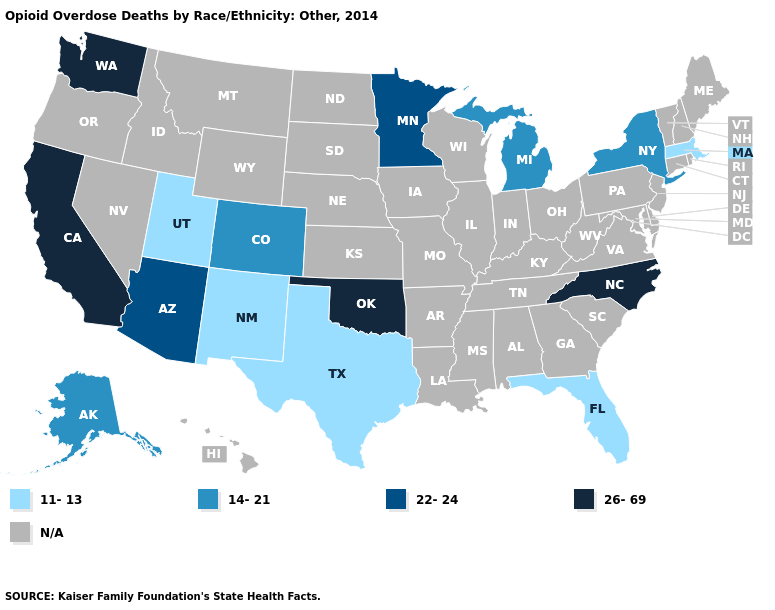Among the states that border Virginia , which have the lowest value?
Keep it brief. North Carolina. Name the states that have a value in the range N/A?
Be succinct. Alabama, Arkansas, Connecticut, Delaware, Georgia, Hawaii, Idaho, Illinois, Indiana, Iowa, Kansas, Kentucky, Louisiana, Maine, Maryland, Mississippi, Missouri, Montana, Nebraska, Nevada, New Hampshire, New Jersey, North Dakota, Ohio, Oregon, Pennsylvania, Rhode Island, South Carolina, South Dakota, Tennessee, Vermont, Virginia, West Virginia, Wisconsin, Wyoming. Among the states that border Kansas , which have the highest value?
Be succinct. Oklahoma. Does the first symbol in the legend represent the smallest category?
Write a very short answer. Yes. Name the states that have a value in the range 22-24?
Short answer required. Arizona, Minnesota. Name the states that have a value in the range 11-13?
Be succinct. Florida, Massachusetts, New Mexico, Texas, Utah. Name the states that have a value in the range 14-21?
Give a very brief answer. Alaska, Colorado, Michigan, New York. What is the lowest value in the MidWest?
Concise answer only. 14-21. What is the highest value in the Northeast ?
Answer briefly. 14-21. What is the value of Rhode Island?
Quick response, please. N/A. What is the value of Texas?
Concise answer only. 11-13. Among the states that border Arizona , which have the lowest value?
Concise answer only. New Mexico, Utah. Is the legend a continuous bar?
Give a very brief answer. No. 